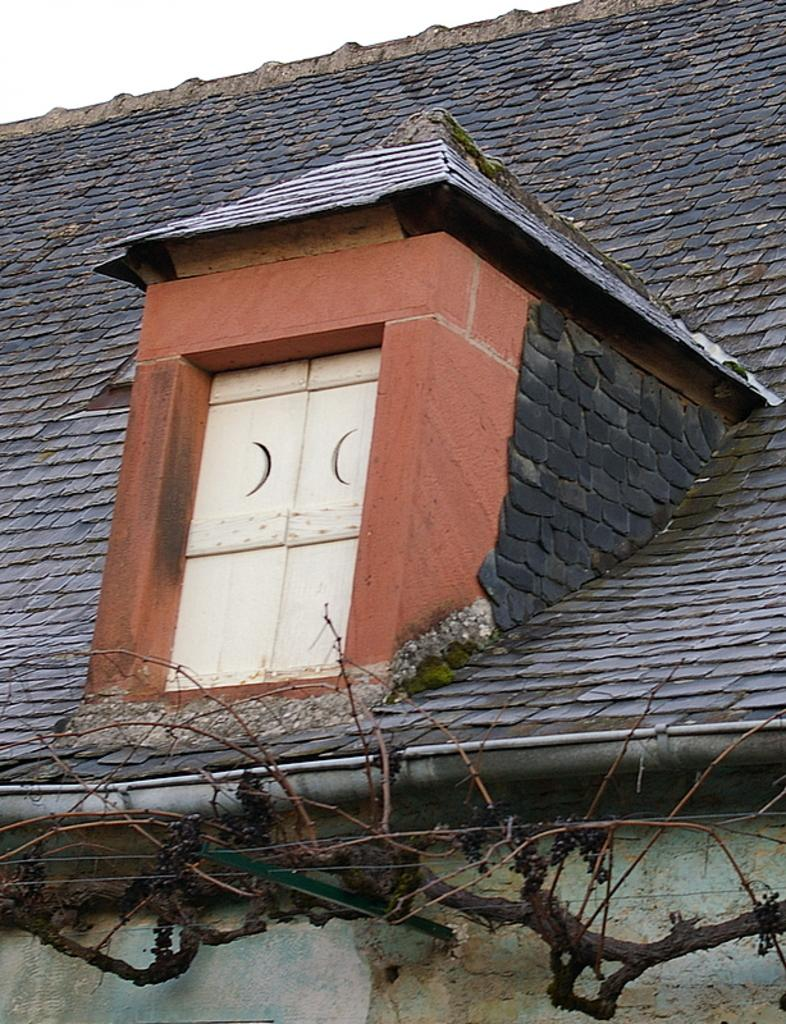What type of structure is visible in the image? There is a roof, window, doors, and a wall visible in the image. Can you describe the architectural features of the structure? The structure has a roof, window, and doors, as well as a wall. What is visible at the bottom of the image? There are sticks at the bottom of the image. What is visible at the top of the image? The sky is visible at the top of the image. Where can the receipt for the purchase of the sign be found in the image? There is no sign or receipt present in the image. What type of drink is being served in the image? There is no drink present in the image. 